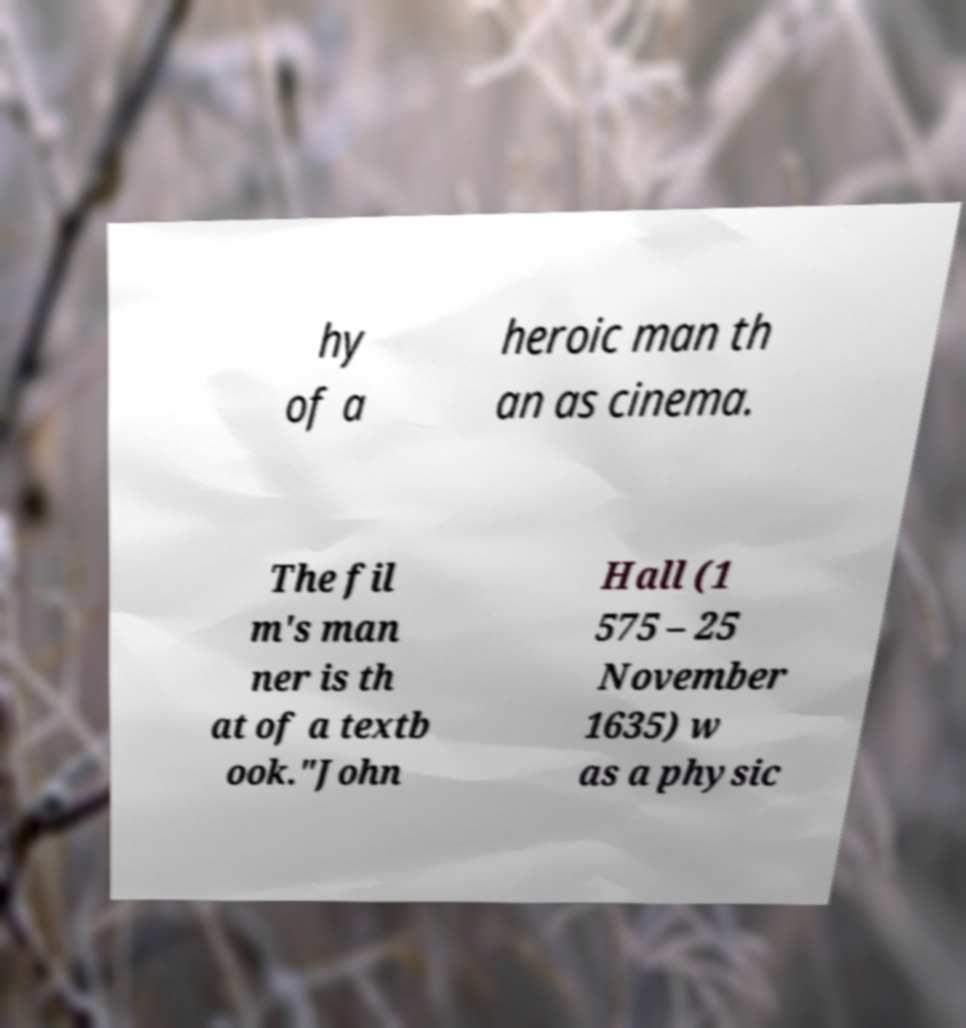Could you extract and type out the text from this image? hy of a heroic man th an as cinema. The fil m's man ner is th at of a textb ook."John Hall (1 575 – 25 November 1635) w as a physic 